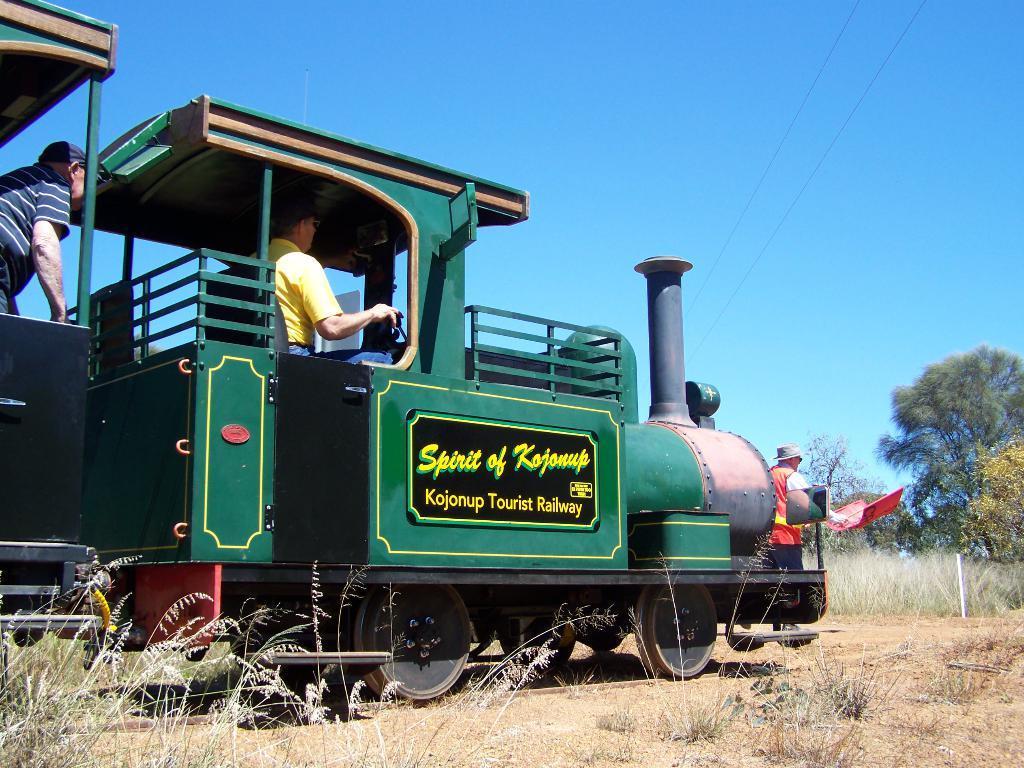Please provide a concise description of this image. In the center of the image, we can see people inside the train and on the right, there is a person standing and holding a flag. In the background, there are trees and at the bottom, there is ground covered with grass. At the top, there is sky. 